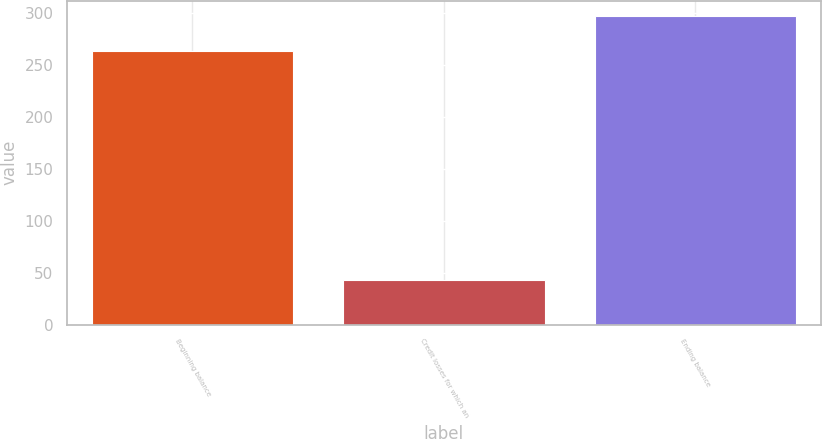<chart> <loc_0><loc_0><loc_500><loc_500><bar_chart><fcel>Beginning balance<fcel>Credit losses for which an<fcel>Ending balance<nl><fcel>263<fcel>43.2<fcel>297<nl></chart> 